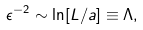<formula> <loc_0><loc_0><loc_500><loc_500>\epsilon ^ { - 2 } \sim \ln [ L / a ] \equiv \Lambda ,</formula> 